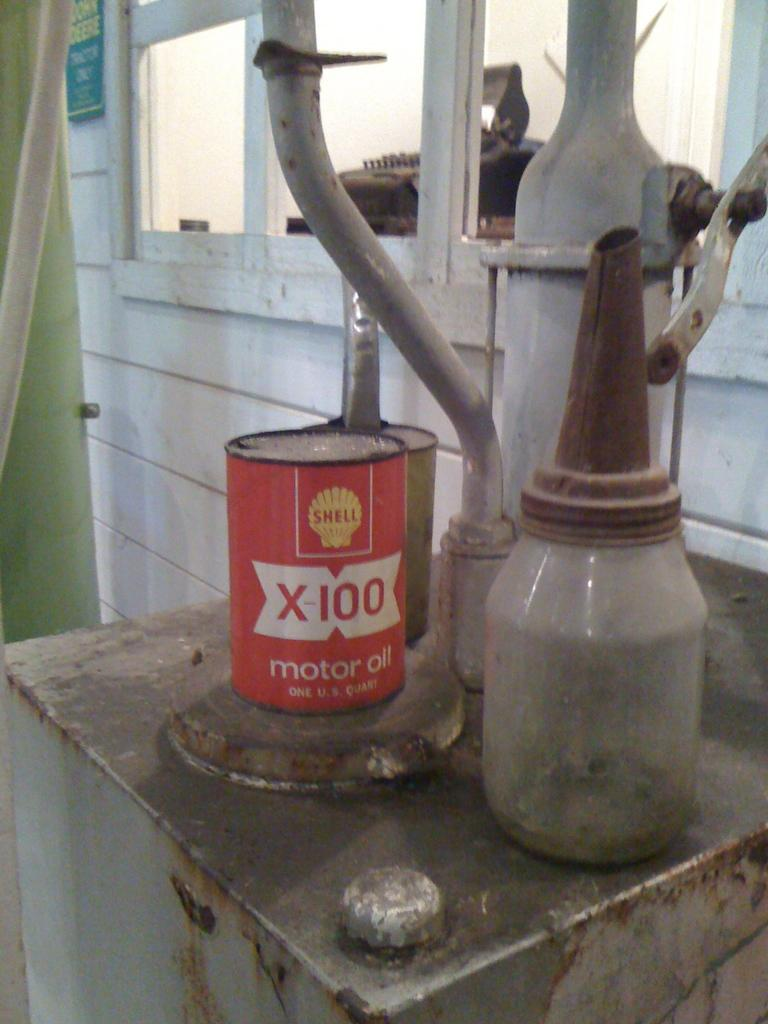<image>
Provide a brief description of the given image. An old can of motor oil sits on a rusty table. 